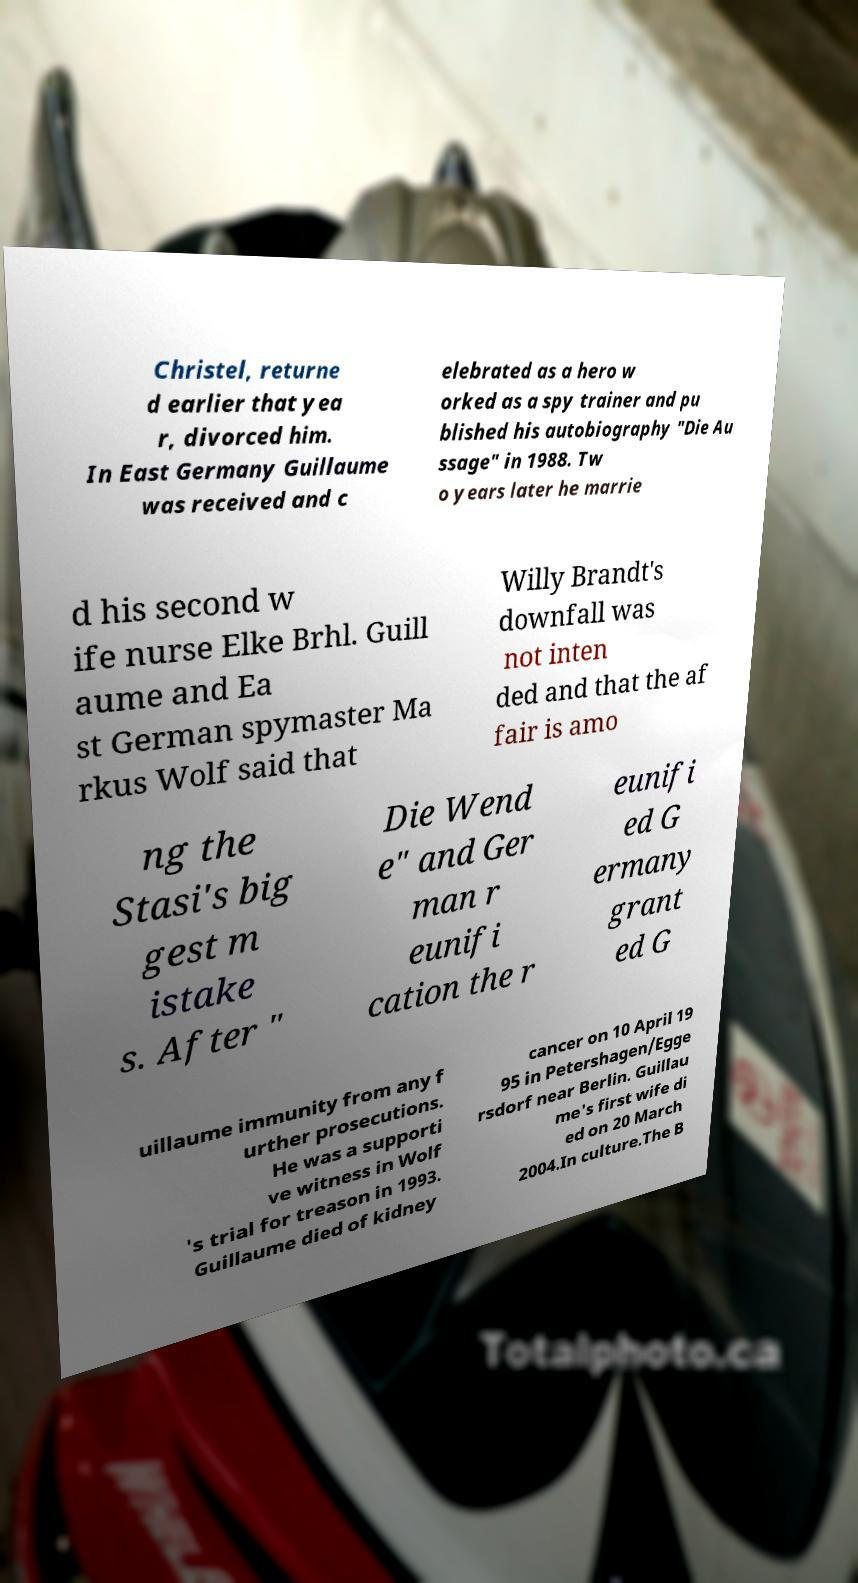There's text embedded in this image that I need extracted. Can you transcribe it verbatim? Christel, returne d earlier that yea r, divorced him. In East Germany Guillaume was received and c elebrated as a hero w orked as a spy trainer and pu blished his autobiography "Die Au ssage" in 1988. Tw o years later he marrie d his second w ife nurse Elke Brhl. Guill aume and Ea st German spymaster Ma rkus Wolf said that Willy Brandt's downfall was not inten ded and that the af fair is amo ng the Stasi's big gest m istake s. After " Die Wend e" and Ger man r eunifi cation the r eunifi ed G ermany grant ed G uillaume immunity from any f urther prosecutions. He was a supporti ve witness in Wolf 's trial for treason in 1993. Guillaume died of kidney cancer on 10 April 19 95 in Petershagen/Egge rsdorf near Berlin. Guillau me's first wife di ed on 20 March 2004.In culture.The B 